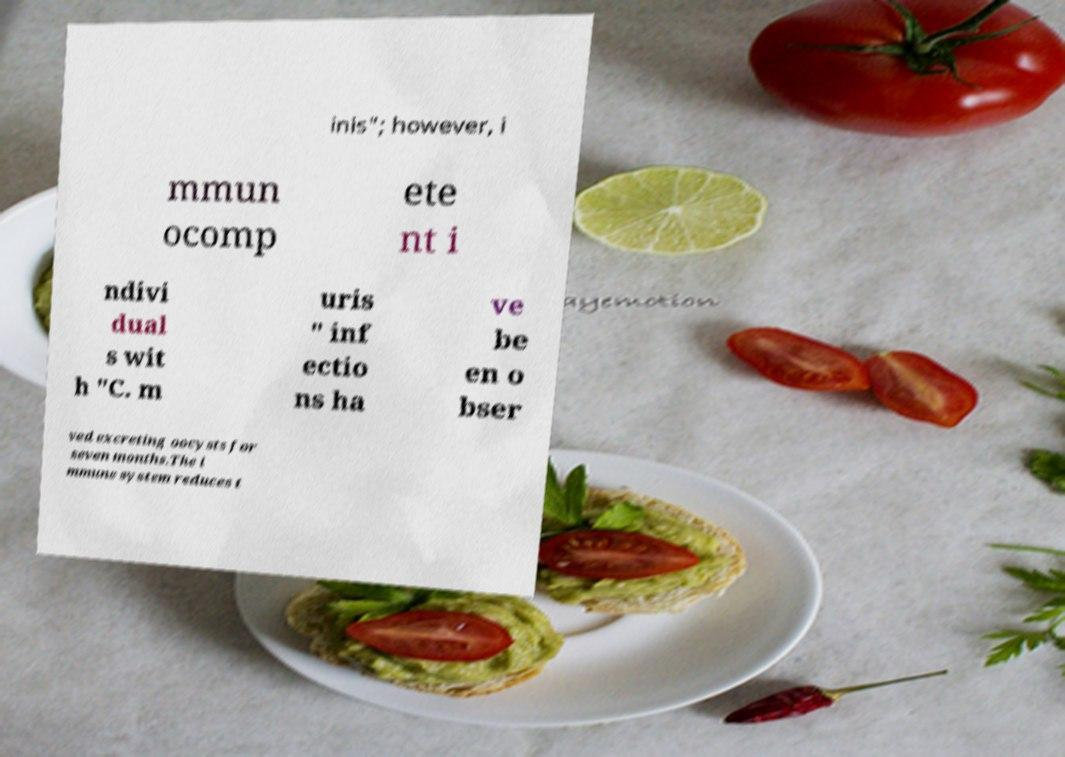Can you accurately transcribe the text from the provided image for me? inis"; however, i mmun ocomp ete nt i ndivi dual s wit h "C. m uris " inf ectio ns ha ve be en o bser ved excreting oocysts for seven months.The i mmune system reduces t 